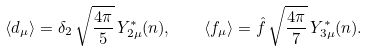<formula> <loc_0><loc_0><loc_500><loc_500>\langle d _ { \mu } \rangle = \delta _ { 2 } \, \sqrt { \frac { 4 \pi } { 5 } } \, Y _ { 2 \mu } ^ { \ast } ( { n } ) , \quad \langle f _ { \mu } \rangle = \hat { f } \, \sqrt { \frac { 4 \pi } { 7 } } \, Y _ { 3 \mu } ^ { \ast } ( { n } ) .</formula> 